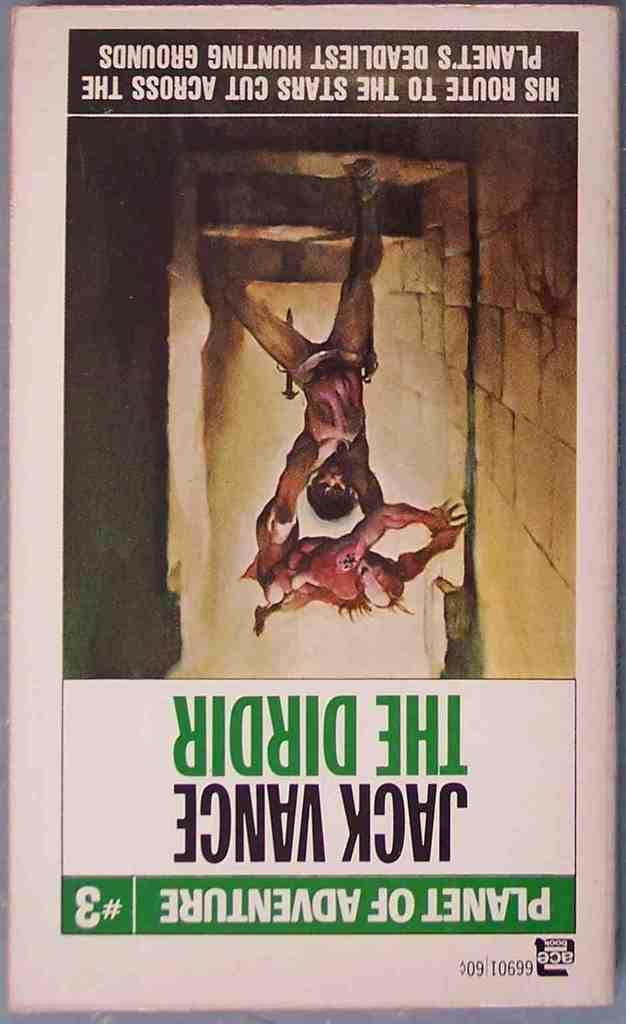<image>
Give a short and clear explanation of the subsequent image. an upside down poster for the dirdir by jack vance in green and black. 